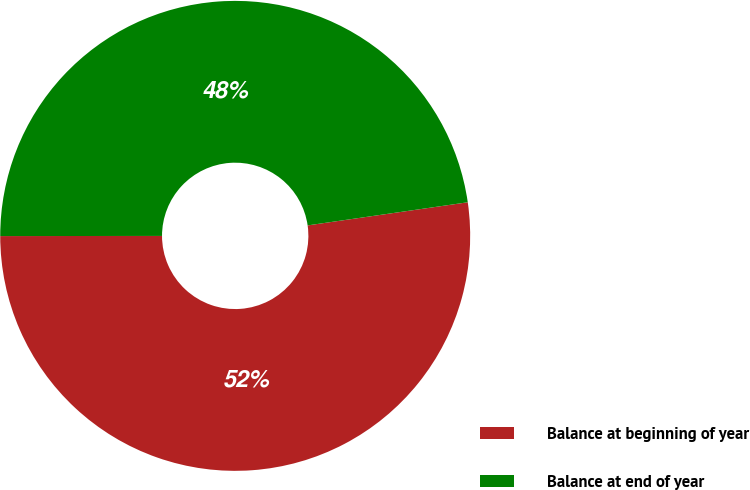<chart> <loc_0><loc_0><loc_500><loc_500><pie_chart><fcel>Balance at beginning of year<fcel>Balance at end of year<nl><fcel>52.27%<fcel>47.73%<nl></chart> 